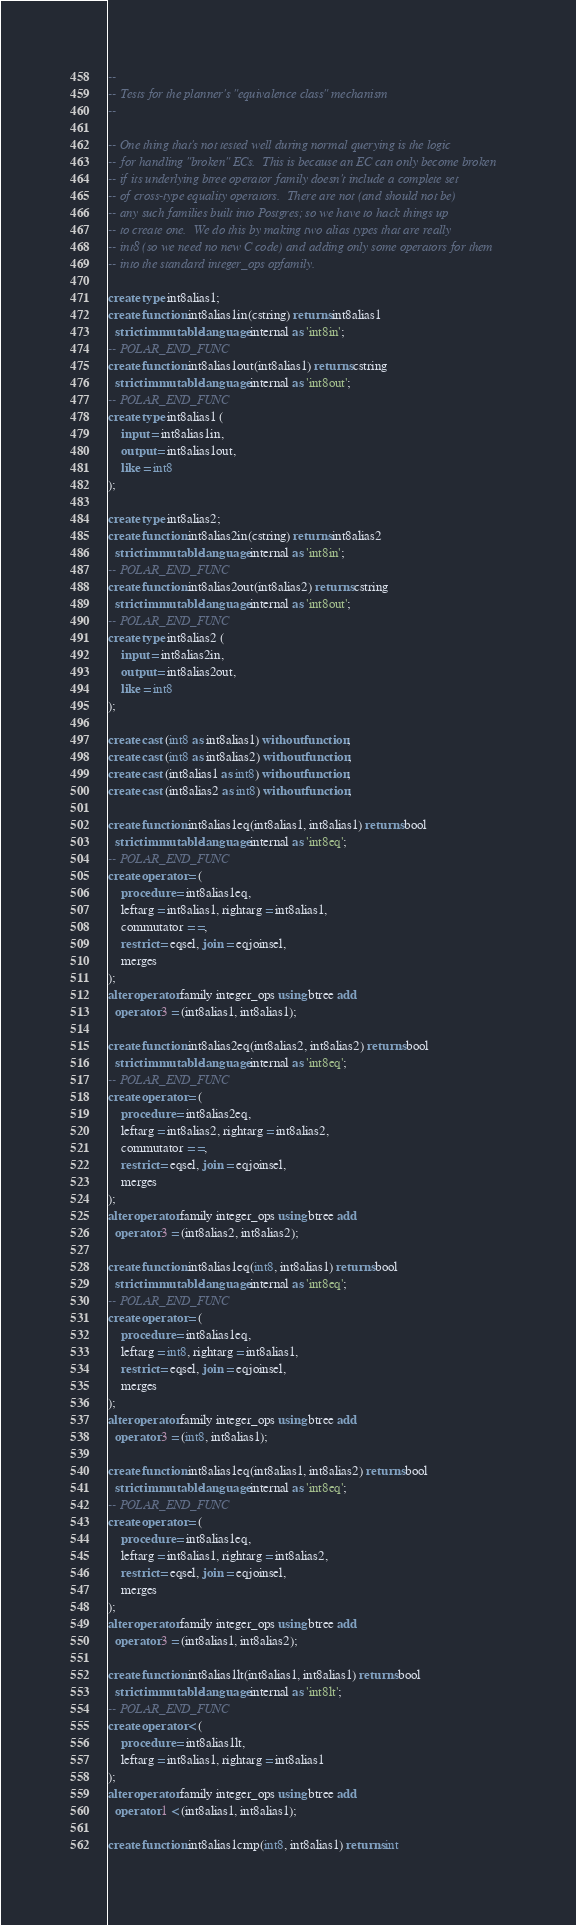<code> <loc_0><loc_0><loc_500><loc_500><_SQL_>--
-- Tests for the planner's "equivalence class" mechanism
--

-- One thing that's not tested well during normal querying is the logic
-- for handling "broken" ECs.  This is because an EC can only become broken
-- if its underlying btree operator family doesn't include a complete set
-- of cross-type equality operators.  There are not (and should not be)
-- any such families built into Postgres; so we have to hack things up
-- to create one.  We do this by making two alias types that are really
-- int8 (so we need no new C code) and adding only some operators for them
-- into the standard integer_ops opfamily.

create type int8alias1;
create function int8alias1in(cstring) returns int8alias1
  strict immutable language internal as 'int8in';
-- POLAR_END_FUNC
create function int8alias1out(int8alias1) returns cstring
  strict immutable language internal as 'int8out';
-- POLAR_END_FUNC
create type int8alias1 (
    input = int8alias1in,
    output = int8alias1out,
    like = int8
);

create type int8alias2;
create function int8alias2in(cstring) returns int8alias2
  strict immutable language internal as 'int8in';
-- POLAR_END_FUNC
create function int8alias2out(int8alias2) returns cstring
  strict immutable language internal as 'int8out';
-- POLAR_END_FUNC
create type int8alias2 (
    input = int8alias2in,
    output = int8alias2out,
    like = int8
);

create cast (int8 as int8alias1) without function;
create cast (int8 as int8alias2) without function;
create cast (int8alias1 as int8) without function;
create cast (int8alias2 as int8) without function;

create function int8alias1eq(int8alias1, int8alias1) returns bool
  strict immutable language internal as 'int8eq';
-- POLAR_END_FUNC
create operator = (
    procedure = int8alias1eq,
    leftarg = int8alias1, rightarg = int8alias1,
    commutator = =,
    restrict = eqsel, join = eqjoinsel,
    merges
);
alter operator family integer_ops using btree add
  operator 3 = (int8alias1, int8alias1);

create function int8alias2eq(int8alias2, int8alias2) returns bool
  strict immutable language internal as 'int8eq';
-- POLAR_END_FUNC
create operator = (
    procedure = int8alias2eq,
    leftarg = int8alias2, rightarg = int8alias2,
    commutator = =,
    restrict = eqsel, join = eqjoinsel,
    merges
);
alter operator family integer_ops using btree add
  operator 3 = (int8alias2, int8alias2);

create function int8alias1eq(int8, int8alias1) returns bool
  strict immutable language internal as 'int8eq';
-- POLAR_END_FUNC
create operator = (
    procedure = int8alias1eq,
    leftarg = int8, rightarg = int8alias1,
    restrict = eqsel, join = eqjoinsel,
    merges
);
alter operator family integer_ops using btree add
  operator 3 = (int8, int8alias1);

create function int8alias1eq(int8alias1, int8alias2) returns bool
  strict immutable language internal as 'int8eq';
-- POLAR_END_FUNC
create operator = (
    procedure = int8alias1eq,
    leftarg = int8alias1, rightarg = int8alias2,
    restrict = eqsel, join = eqjoinsel,
    merges
);
alter operator family integer_ops using btree add
  operator 3 = (int8alias1, int8alias2);

create function int8alias1lt(int8alias1, int8alias1) returns bool
  strict immutable language internal as 'int8lt';
-- POLAR_END_FUNC
create operator < (
    procedure = int8alias1lt,
    leftarg = int8alias1, rightarg = int8alias1
);
alter operator family integer_ops using btree add
  operator 1 < (int8alias1, int8alias1);

create function int8alias1cmp(int8, int8alias1) returns int</code> 